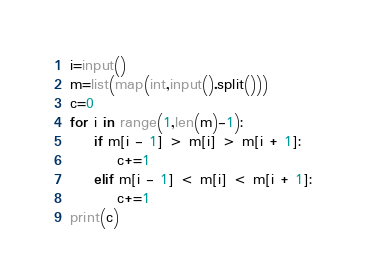<code> <loc_0><loc_0><loc_500><loc_500><_Python_>i=input()
m=list(map(int,input().split()))
c=0
for i in range(1,len(m)-1):
    if m[i - 1] > m[i] > m[i + 1]:
        c+=1
    elif m[i - 1] < m[i] < m[i + 1]:
        c+=1
print(c)


</code> 